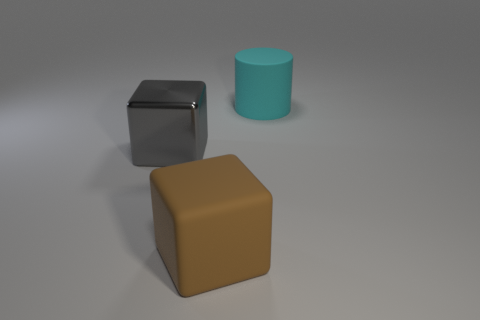Add 2 matte cylinders. How many objects exist? 5 Subtract all cylinders. How many objects are left? 2 Subtract 0 green cubes. How many objects are left? 3 Subtract all yellow metal cylinders. Subtract all cylinders. How many objects are left? 2 Add 1 gray metal things. How many gray metal things are left? 2 Add 2 gray objects. How many gray objects exist? 3 